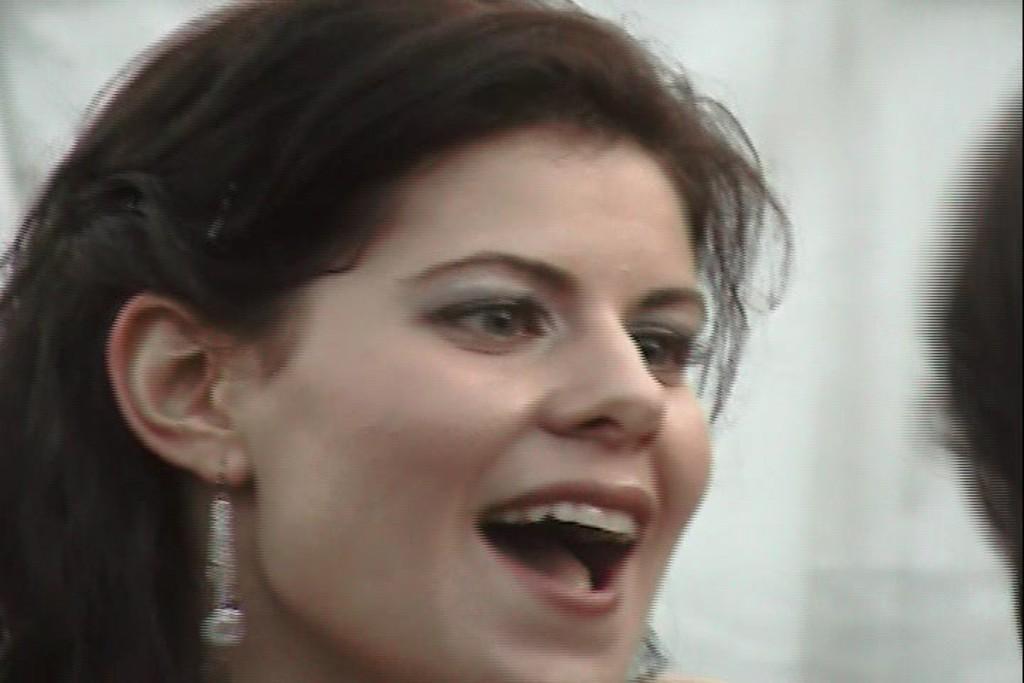How would you summarize this image in a sentence or two? In this image I can see a woman is smiling by looking at the right side. On the right side, I can see a person's head. The background is blurred. 